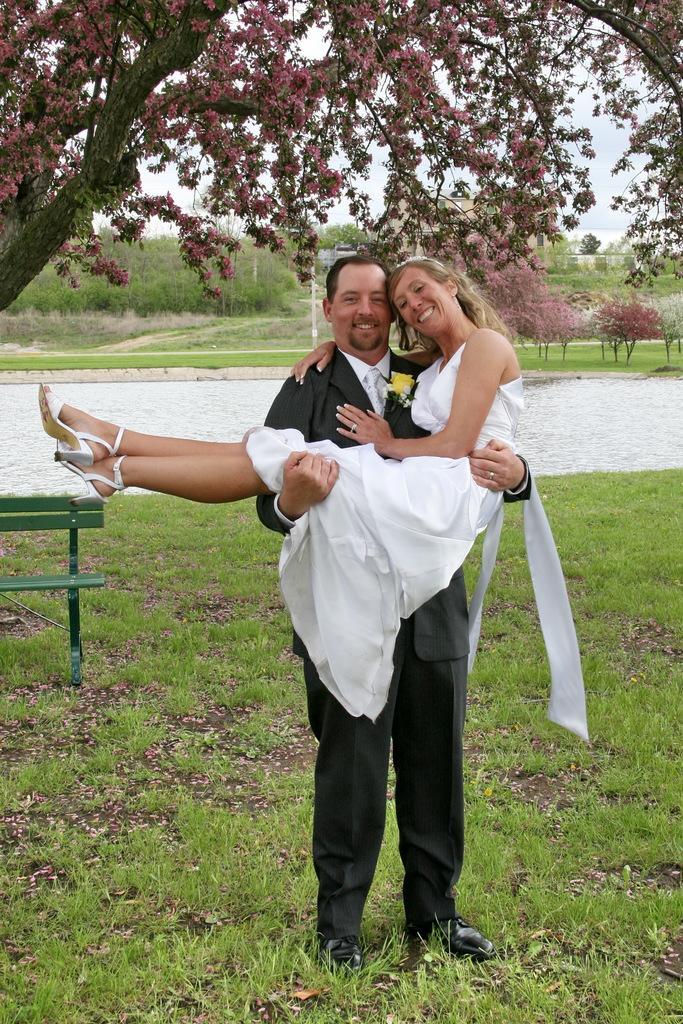In one or two sentences, can you explain what this image depicts? In this image we can see a man carrying a woman, there is a bench, trees, plants, grass, also we can see the sky.  